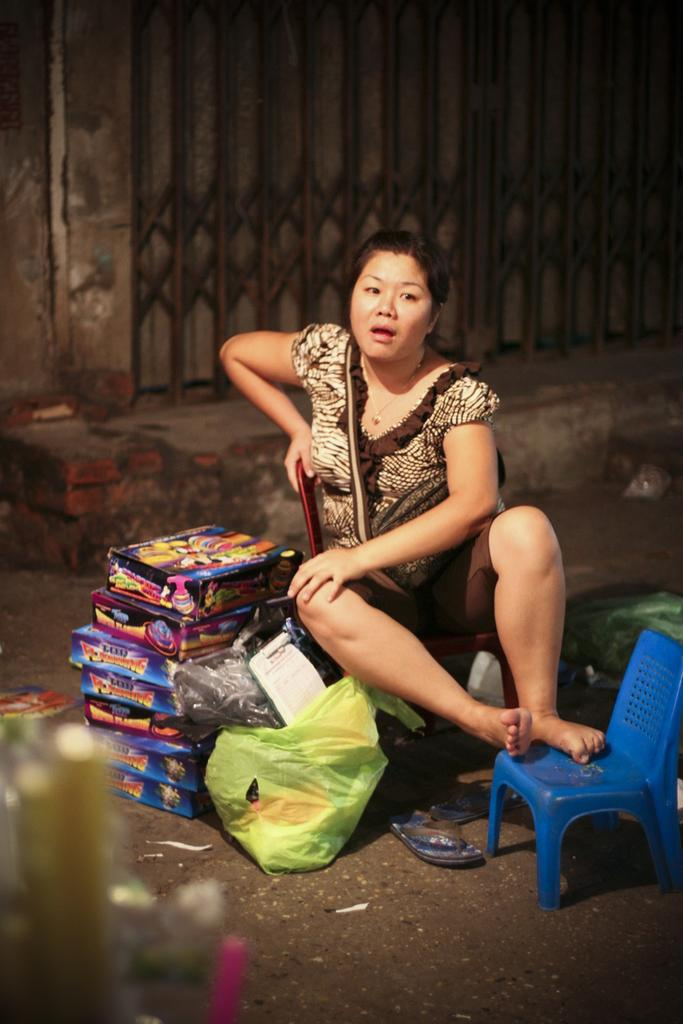What is the woman doing in the image? The woman is sitting on the road with her legs placed on a chair. What is the woman using to support her legs? The woman is using a chair to support her legs. What objects can be seen behind the woman? There are boxes behind the woman. What is in front of the woman? There is a cover in front of the woman. What can be seen in the background of the image? There is a gate and a wall in the background of the image. What taste does the representative of the gate in the background have? There is no representative of the gate in the background, and therefore no taste can be associated with it. 